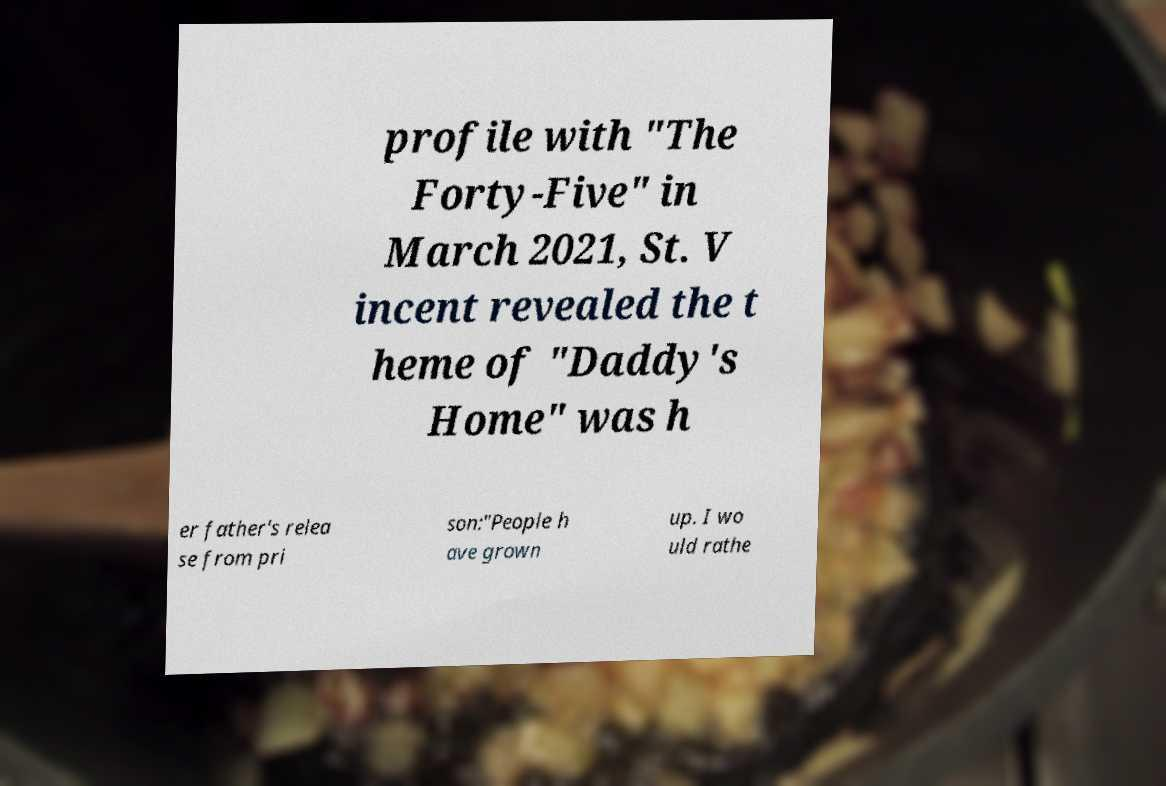Please read and relay the text visible in this image. What does it say? profile with "The Forty-Five" in March 2021, St. V incent revealed the t heme of "Daddy's Home" was h er father's relea se from pri son:"People h ave grown up. I wo uld rathe 